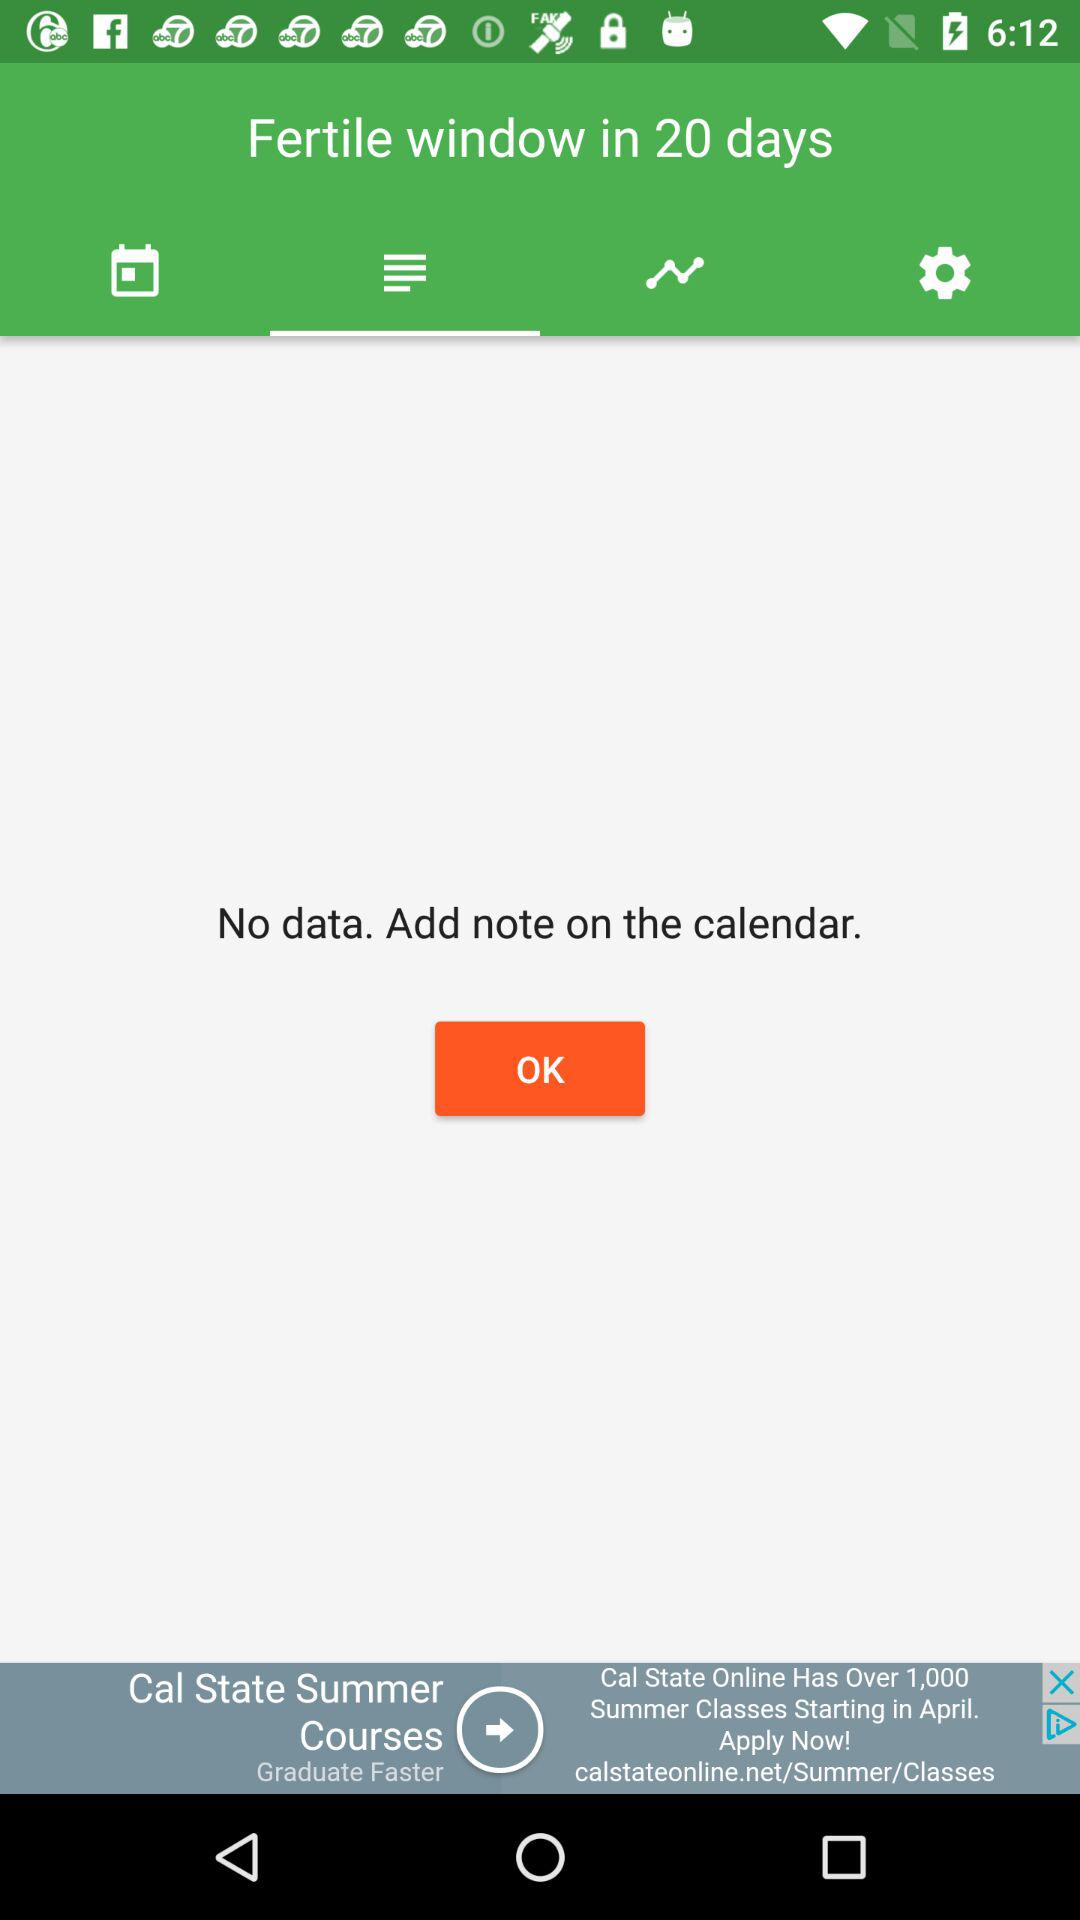How many days until the fertile window?
Answer the question using a single word or phrase. 20 